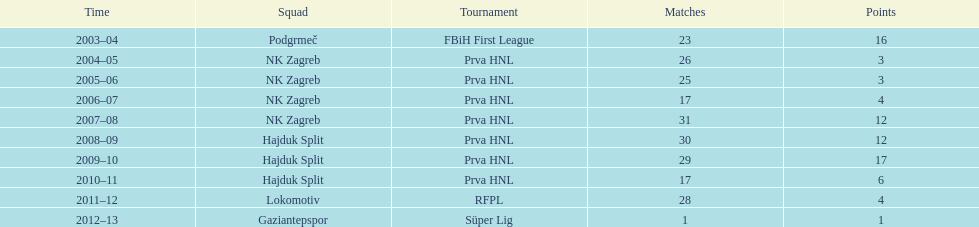What were the names of each club where more than 15 goals were scored in a single season? Podgrmeč, Hajduk Split. 